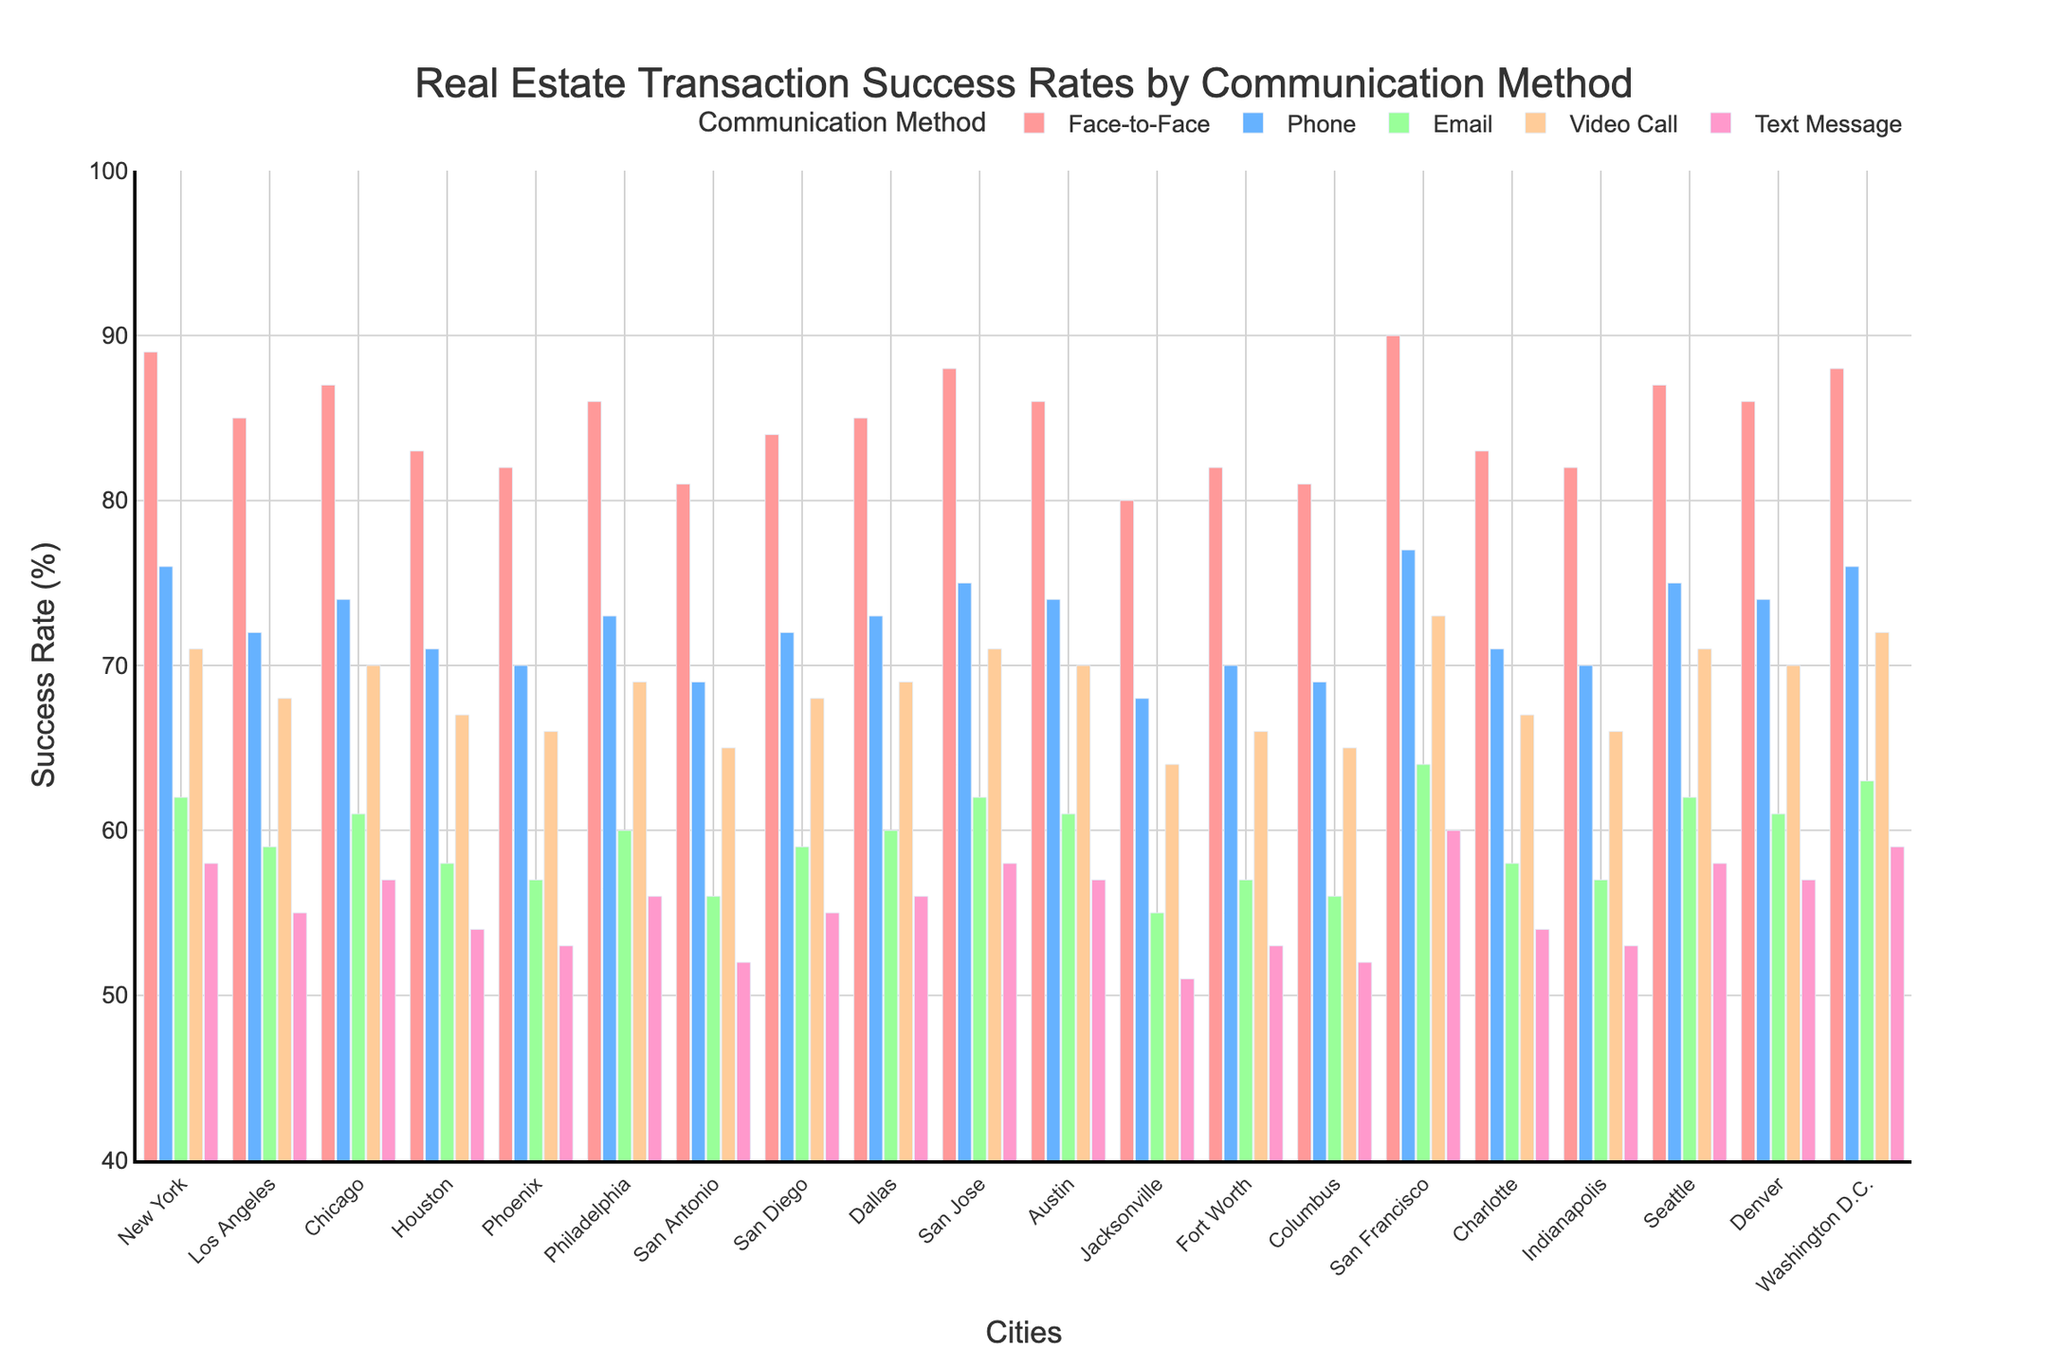What's the title of the plot? The title of the plot is displayed at the top center of the figure. It provides the main subject of the plot which helps viewers quickly understand what the figure represents.
Answer: Real Estate Transaction Success Rates by Communication Method What is the range of the Success Rate (%) on the Y-axis? The Y-axis has a numerical range, which starts at its minimum value and ends at its maximum value. Looking at the axis, you can see the range it covers.
Answer: 40-100 Which communication method has the highest success rate in New York? Locate the bar corresponding to New York, and check which color (representing a communication method) reaches the highest point on the Y-axis.
Answer: Face-to-Face How many cities have a face-to-face success rate above 85%? Examine the bars for each city representing Face-to-Face communication (typically in the same color), and count those that have a value above 85% on the Y-axis.
Answer: 10 Compare the success rates of Face-to-Face and Email communication methods in San Francisco. Which one is higher, and by how much? Look at the bars for Face-to-Face and Email in San Francisco and compare their heights. Subtract the smaller success rate from the larger one to find the difference.
Answer: Face-to-Face is higher by 26% Which city has the lowest success rate for Text Message communication? Identify the bars representing Text Message communication across all cities, and find the one with the lowest value on the Y-axis.
Answer: Jacksonville What is the average success rate of Phone communication across all cities? Sum up the success rate values for all cities for Phone communication and then divide by the number of cities to find the average.
Answer: 73.05 Is there any city where Video Call and Text Message success rates are the same? Check the bars for Video Call and Text Message success rates in each city to see if there are any cities where the heights of these bars match.
Answer: No Which city shows the largest difference between the highest and lowest success rates across all communication methods? For each city, find the highest and lowest success rates among all communication methods and calculate the difference. Compare these differences to find the largest one.
Answer: San Francisco How does the success rate of Email communication in Los Angeles compare to that in Dallas? Locate the bars representing Email communication in Los Angeles and Dallas and compare their heights to see which is higher and by how much.
Answer: Los Angeles is 1% lower 